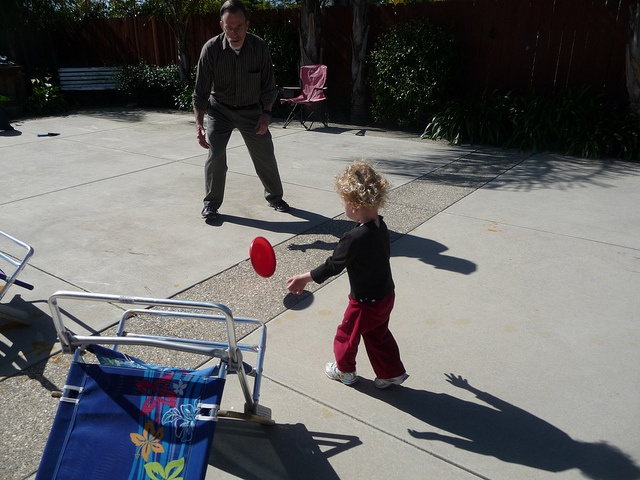Describe the objects in this image and their specific colors. I can see chair in black, navy, darkgray, and gray tones, people in black, maroon, gray, and darkgray tones, people in black, gray, maroon, and darkgray tones, chair in black, purple, brown, and gray tones, and bench in black, darkblue, and purple tones in this image. 